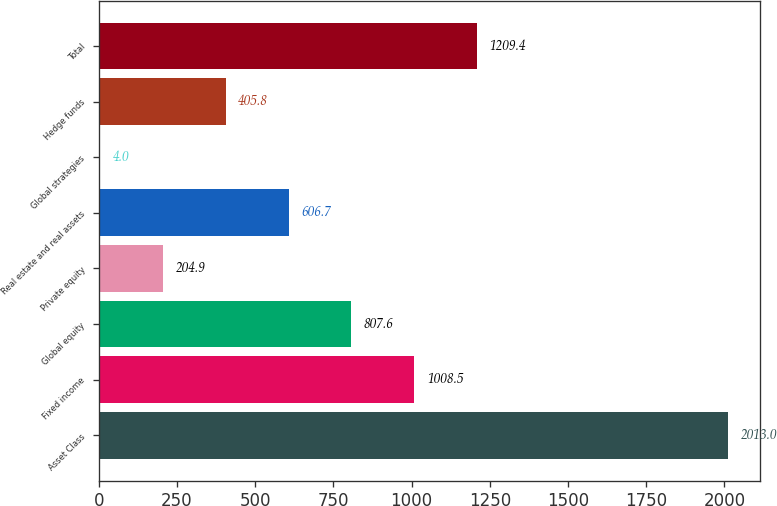<chart> <loc_0><loc_0><loc_500><loc_500><bar_chart><fcel>Asset Class<fcel>Fixed income<fcel>Global equity<fcel>Private equity<fcel>Real estate and real assets<fcel>Global strategies<fcel>Hedge funds<fcel>Total<nl><fcel>2013<fcel>1008.5<fcel>807.6<fcel>204.9<fcel>606.7<fcel>4<fcel>405.8<fcel>1209.4<nl></chart> 